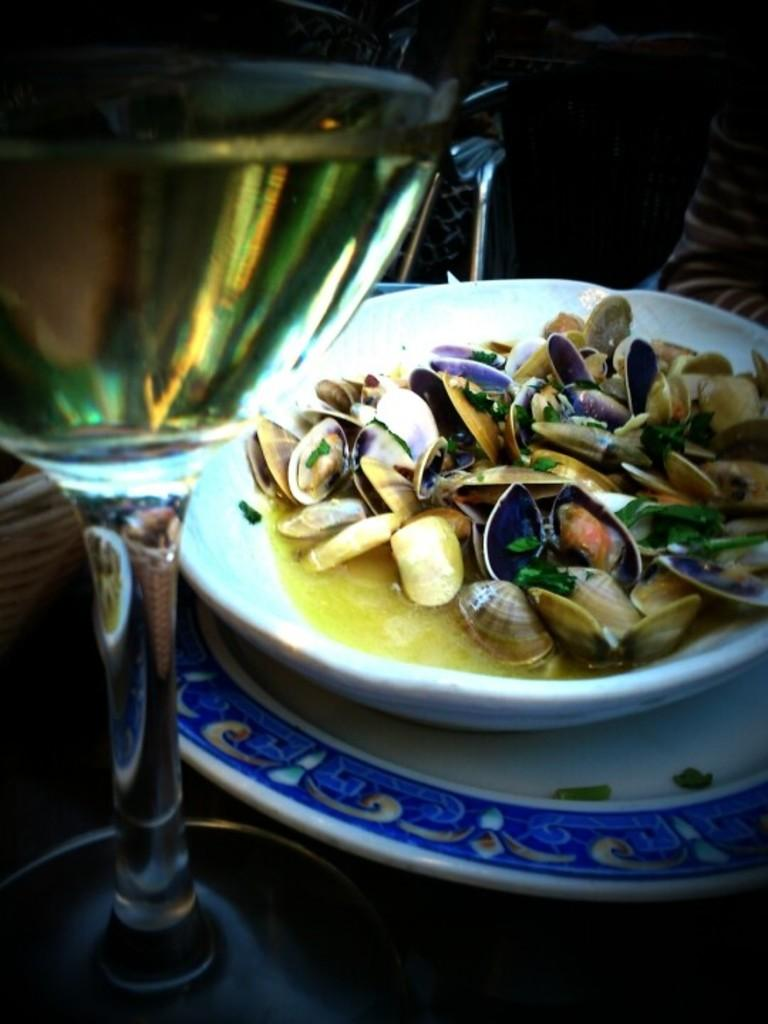What is on the plate in the image? There is a bowl on the plate in the image. What is inside the bowl? The bowl contains shells. Where is the glass located in the image? The glass is on the left side of the image. What is in the glass? The glass contains a drink. What type of design can be seen on the animal in the image? There is no animal present in the image; it features a plate with a bowl of shells and a glass with a drink. 